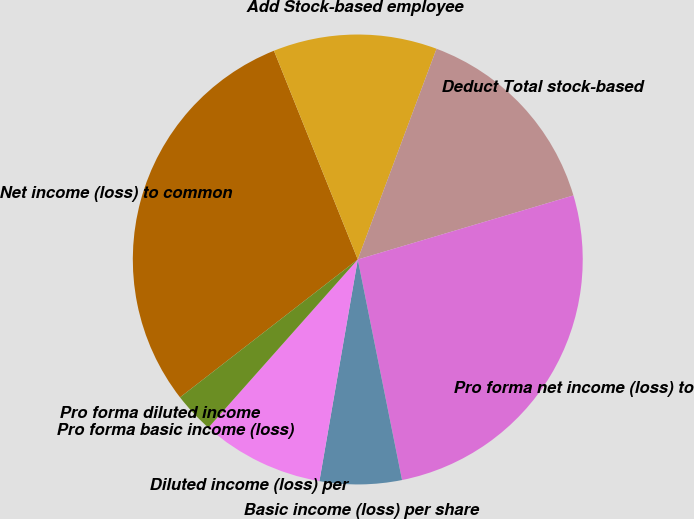Convert chart. <chart><loc_0><loc_0><loc_500><loc_500><pie_chart><fcel>Net income (loss) to common<fcel>Add Stock-based employee<fcel>Deduct Total stock-based<fcel>Pro forma net income (loss) to<fcel>Basic income (loss) per share<fcel>Diluted income (loss) per<fcel>Pro forma basic income (loss)<fcel>Pro forma diluted income<nl><fcel>29.42%<fcel>11.77%<fcel>14.71%<fcel>26.44%<fcel>5.88%<fcel>8.83%<fcel>2.94%<fcel>0.0%<nl></chart> 